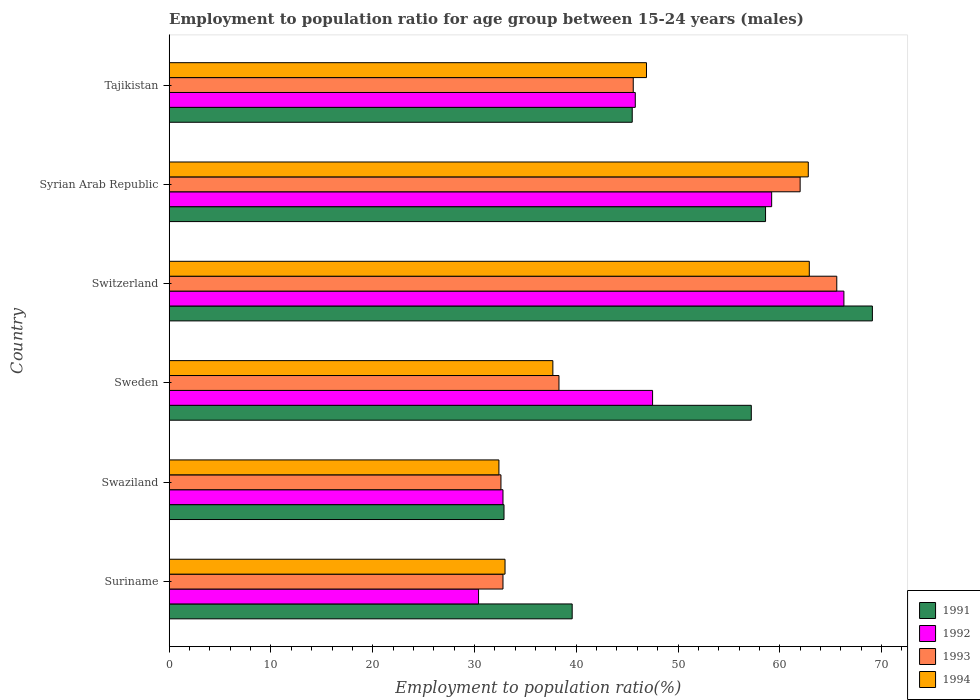How many groups of bars are there?
Offer a very short reply. 6. How many bars are there on the 6th tick from the top?
Offer a very short reply. 4. What is the label of the 1st group of bars from the top?
Give a very brief answer. Tajikistan. What is the employment to population ratio in 1991 in Swaziland?
Make the answer very short. 32.9. Across all countries, what is the maximum employment to population ratio in 1994?
Ensure brevity in your answer.  62.9. Across all countries, what is the minimum employment to population ratio in 1994?
Your response must be concise. 32.4. In which country was the employment to population ratio in 1992 maximum?
Offer a very short reply. Switzerland. In which country was the employment to population ratio in 1992 minimum?
Provide a short and direct response. Suriname. What is the total employment to population ratio in 1992 in the graph?
Keep it short and to the point. 282. What is the difference between the employment to population ratio in 1991 in Switzerland and that in Syrian Arab Republic?
Your answer should be compact. 10.5. What is the difference between the employment to population ratio in 1992 in Switzerland and the employment to population ratio in 1991 in Suriname?
Give a very brief answer. 26.7. What is the average employment to population ratio in 1994 per country?
Your response must be concise. 45.95. What is the ratio of the employment to population ratio in 1992 in Sweden to that in Tajikistan?
Give a very brief answer. 1.04. Is the employment to population ratio in 1992 in Suriname less than that in Swaziland?
Offer a terse response. Yes. What is the difference between the highest and the second highest employment to population ratio in 1991?
Provide a succinct answer. 10.5. What is the difference between the highest and the lowest employment to population ratio in 1994?
Your answer should be very brief. 30.5. Is it the case that in every country, the sum of the employment to population ratio in 1994 and employment to population ratio in 1992 is greater than the sum of employment to population ratio in 1993 and employment to population ratio in 1991?
Your answer should be compact. No. What does the 3rd bar from the bottom in Tajikistan represents?
Ensure brevity in your answer.  1993. Is it the case that in every country, the sum of the employment to population ratio in 1994 and employment to population ratio in 1992 is greater than the employment to population ratio in 1991?
Your response must be concise. Yes. How many countries are there in the graph?
Your response must be concise. 6. Does the graph contain grids?
Offer a terse response. No. Where does the legend appear in the graph?
Offer a terse response. Bottom right. How many legend labels are there?
Keep it short and to the point. 4. What is the title of the graph?
Your answer should be very brief. Employment to population ratio for age group between 15-24 years (males). Does "1966" appear as one of the legend labels in the graph?
Offer a terse response. No. What is the label or title of the Y-axis?
Give a very brief answer. Country. What is the Employment to population ratio(%) in 1991 in Suriname?
Keep it short and to the point. 39.6. What is the Employment to population ratio(%) in 1992 in Suriname?
Provide a short and direct response. 30.4. What is the Employment to population ratio(%) of 1993 in Suriname?
Give a very brief answer. 32.8. What is the Employment to population ratio(%) in 1994 in Suriname?
Make the answer very short. 33. What is the Employment to population ratio(%) in 1991 in Swaziland?
Your answer should be compact. 32.9. What is the Employment to population ratio(%) in 1992 in Swaziland?
Give a very brief answer. 32.8. What is the Employment to population ratio(%) of 1993 in Swaziland?
Provide a succinct answer. 32.6. What is the Employment to population ratio(%) in 1994 in Swaziland?
Keep it short and to the point. 32.4. What is the Employment to population ratio(%) in 1991 in Sweden?
Provide a short and direct response. 57.2. What is the Employment to population ratio(%) of 1992 in Sweden?
Ensure brevity in your answer.  47.5. What is the Employment to population ratio(%) in 1993 in Sweden?
Provide a short and direct response. 38.3. What is the Employment to population ratio(%) in 1994 in Sweden?
Offer a terse response. 37.7. What is the Employment to population ratio(%) in 1991 in Switzerland?
Your answer should be very brief. 69.1. What is the Employment to population ratio(%) of 1992 in Switzerland?
Make the answer very short. 66.3. What is the Employment to population ratio(%) of 1993 in Switzerland?
Your answer should be compact. 65.6. What is the Employment to population ratio(%) of 1994 in Switzerland?
Ensure brevity in your answer.  62.9. What is the Employment to population ratio(%) of 1991 in Syrian Arab Republic?
Your response must be concise. 58.6. What is the Employment to population ratio(%) of 1992 in Syrian Arab Republic?
Offer a very short reply. 59.2. What is the Employment to population ratio(%) of 1993 in Syrian Arab Republic?
Make the answer very short. 62. What is the Employment to population ratio(%) of 1994 in Syrian Arab Republic?
Give a very brief answer. 62.8. What is the Employment to population ratio(%) in 1991 in Tajikistan?
Make the answer very short. 45.5. What is the Employment to population ratio(%) of 1992 in Tajikistan?
Make the answer very short. 45.8. What is the Employment to population ratio(%) in 1993 in Tajikistan?
Make the answer very short. 45.6. What is the Employment to population ratio(%) in 1994 in Tajikistan?
Give a very brief answer. 46.9. Across all countries, what is the maximum Employment to population ratio(%) in 1991?
Give a very brief answer. 69.1. Across all countries, what is the maximum Employment to population ratio(%) in 1992?
Provide a succinct answer. 66.3. Across all countries, what is the maximum Employment to population ratio(%) of 1993?
Make the answer very short. 65.6. Across all countries, what is the maximum Employment to population ratio(%) of 1994?
Provide a succinct answer. 62.9. Across all countries, what is the minimum Employment to population ratio(%) of 1991?
Your answer should be compact. 32.9. Across all countries, what is the minimum Employment to population ratio(%) of 1992?
Your response must be concise. 30.4. Across all countries, what is the minimum Employment to population ratio(%) in 1993?
Provide a short and direct response. 32.6. Across all countries, what is the minimum Employment to population ratio(%) in 1994?
Your answer should be very brief. 32.4. What is the total Employment to population ratio(%) of 1991 in the graph?
Make the answer very short. 302.9. What is the total Employment to population ratio(%) of 1992 in the graph?
Provide a succinct answer. 282. What is the total Employment to population ratio(%) in 1993 in the graph?
Offer a very short reply. 276.9. What is the total Employment to population ratio(%) of 1994 in the graph?
Offer a very short reply. 275.7. What is the difference between the Employment to population ratio(%) of 1992 in Suriname and that in Swaziland?
Your answer should be very brief. -2.4. What is the difference between the Employment to population ratio(%) in 1991 in Suriname and that in Sweden?
Provide a succinct answer. -17.6. What is the difference between the Employment to population ratio(%) in 1992 in Suriname and that in Sweden?
Give a very brief answer. -17.1. What is the difference between the Employment to population ratio(%) in 1993 in Suriname and that in Sweden?
Your answer should be very brief. -5.5. What is the difference between the Employment to population ratio(%) in 1994 in Suriname and that in Sweden?
Offer a very short reply. -4.7. What is the difference between the Employment to population ratio(%) in 1991 in Suriname and that in Switzerland?
Give a very brief answer. -29.5. What is the difference between the Employment to population ratio(%) of 1992 in Suriname and that in Switzerland?
Offer a terse response. -35.9. What is the difference between the Employment to population ratio(%) of 1993 in Suriname and that in Switzerland?
Provide a short and direct response. -32.8. What is the difference between the Employment to population ratio(%) in 1994 in Suriname and that in Switzerland?
Keep it short and to the point. -29.9. What is the difference between the Employment to population ratio(%) of 1991 in Suriname and that in Syrian Arab Republic?
Offer a terse response. -19. What is the difference between the Employment to population ratio(%) of 1992 in Suriname and that in Syrian Arab Republic?
Ensure brevity in your answer.  -28.8. What is the difference between the Employment to population ratio(%) of 1993 in Suriname and that in Syrian Arab Republic?
Your response must be concise. -29.2. What is the difference between the Employment to population ratio(%) in 1994 in Suriname and that in Syrian Arab Republic?
Ensure brevity in your answer.  -29.8. What is the difference between the Employment to population ratio(%) in 1992 in Suriname and that in Tajikistan?
Offer a terse response. -15.4. What is the difference between the Employment to population ratio(%) of 1991 in Swaziland and that in Sweden?
Provide a succinct answer. -24.3. What is the difference between the Employment to population ratio(%) in 1992 in Swaziland and that in Sweden?
Your response must be concise. -14.7. What is the difference between the Employment to population ratio(%) in 1991 in Swaziland and that in Switzerland?
Provide a succinct answer. -36.2. What is the difference between the Employment to population ratio(%) of 1992 in Swaziland and that in Switzerland?
Ensure brevity in your answer.  -33.5. What is the difference between the Employment to population ratio(%) of 1993 in Swaziland and that in Switzerland?
Make the answer very short. -33. What is the difference between the Employment to population ratio(%) in 1994 in Swaziland and that in Switzerland?
Keep it short and to the point. -30.5. What is the difference between the Employment to population ratio(%) of 1991 in Swaziland and that in Syrian Arab Republic?
Offer a terse response. -25.7. What is the difference between the Employment to population ratio(%) in 1992 in Swaziland and that in Syrian Arab Republic?
Provide a succinct answer. -26.4. What is the difference between the Employment to population ratio(%) of 1993 in Swaziland and that in Syrian Arab Republic?
Provide a succinct answer. -29.4. What is the difference between the Employment to population ratio(%) of 1994 in Swaziland and that in Syrian Arab Republic?
Your answer should be compact. -30.4. What is the difference between the Employment to population ratio(%) in 1992 in Swaziland and that in Tajikistan?
Keep it short and to the point. -13. What is the difference between the Employment to population ratio(%) in 1993 in Swaziland and that in Tajikistan?
Your response must be concise. -13. What is the difference between the Employment to population ratio(%) in 1994 in Swaziland and that in Tajikistan?
Offer a terse response. -14.5. What is the difference between the Employment to population ratio(%) of 1991 in Sweden and that in Switzerland?
Provide a short and direct response. -11.9. What is the difference between the Employment to population ratio(%) of 1992 in Sweden and that in Switzerland?
Your answer should be very brief. -18.8. What is the difference between the Employment to population ratio(%) in 1993 in Sweden and that in Switzerland?
Offer a very short reply. -27.3. What is the difference between the Employment to population ratio(%) of 1994 in Sweden and that in Switzerland?
Make the answer very short. -25.2. What is the difference between the Employment to population ratio(%) in 1993 in Sweden and that in Syrian Arab Republic?
Offer a terse response. -23.7. What is the difference between the Employment to population ratio(%) of 1994 in Sweden and that in Syrian Arab Republic?
Your response must be concise. -25.1. What is the difference between the Employment to population ratio(%) of 1991 in Sweden and that in Tajikistan?
Give a very brief answer. 11.7. What is the difference between the Employment to population ratio(%) of 1992 in Sweden and that in Tajikistan?
Your response must be concise. 1.7. What is the difference between the Employment to population ratio(%) of 1993 in Sweden and that in Tajikistan?
Give a very brief answer. -7.3. What is the difference between the Employment to population ratio(%) of 1991 in Switzerland and that in Syrian Arab Republic?
Your answer should be very brief. 10.5. What is the difference between the Employment to population ratio(%) in 1992 in Switzerland and that in Syrian Arab Republic?
Offer a very short reply. 7.1. What is the difference between the Employment to population ratio(%) in 1993 in Switzerland and that in Syrian Arab Republic?
Give a very brief answer. 3.6. What is the difference between the Employment to population ratio(%) in 1994 in Switzerland and that in Syrian Arab Republic?
Your answer should be very brief. 0.1. What is the difference between the Employment to population ratio(%) in 1991 in Switzerland and that in Tajikistan?
Make the answer very short. 23.6. What is the difference between the Employment to population ratio(%) of 1991 in Syrian Arab Republic and that in Tajikistan?
Offer a terse response. 13.1. What is the difference between the Employment to population ratio(%) of 1994 in Syrian Arab Republic and that in Tajikistan?
Keep it short and to the point. 15.9. What is the difference between the Employment to population ratio(%) in 1991 in Suriname and the Employment to population ratio(%) in 1993 in Swaziland?
Your answer should be compact. 7. What is the difference between the Employment to population ratio(%) in 1992 in Suriname and the Employment to population ratio(%) in 1994 in Swaziland?
Your answer should be very brief. -2. What is the difference between the Employment to population ratio(%) in 1991 in Suriname and the Employment to population ratio(%) in 1992 in Sweden?
Make the answer very short. -7.9. What is the difference between the Employment to population ratio(%) of 1992 in Suriname and the Employment to population ratio(%) of 1993 in Sweden?
Offer a terse response. -7.9. What is the difference between the Employment to population ratio(%) in 1991 in Suriname and the Employment to population ratio(%) in 1992 in Switzerland?
Your response must be concise. -26.7. What is the difference between the Employment to population ratio(%) of 1991 in Suriname and the Employment to population ratio(%) of 1993 in Switzerland?
Provide a short and direct response. -26. What is the difference between the Employment to population ratio(%) of 1991 in Suriname and the Employment to population ratio(%) of 1994 in Switzerland?
Offer a terse response. -23.3. What is the difference between the Employment to population ratio(%) in 1992 in Suriname and the Employment to population ratio(%) in 1993 in Switzerland?
Make the answer very short. -35.2. What is the difference between the Employment to population ratio(%) in 1992 in Suriname and the Employment to population ratio(%) in 1994 in Switzerland?
Offer a terse response. -32.5. What is the difference between the Employment to population ratio(%) in 1993 in Suriname and the Employment to population ratio(%) in 1994 in Switzerland?
Offer a very short reply. -30.1. What is the difference between the Employment to population ratio(%) of 1991 in Suriname and the Employment to population ratio(%) of 1992 in Syrian Arab Republic?
Your response must be concise. -19.6. What is the difference between the Employment to population ratio(%) in 1991 in Suriname and the Employment to population ratio(%) in 1993 in Syrian Arab Republic?
Your response must be concise. -22.4. What is the difference between the Employment to population ratio(%) in 1991 in Suriname and the Employment to population ratio(%) in 1994 in Syrian Arab Republic?
Offer a terse response. -23.2. What is the difference between the Employment to population ratio(%) in 1992 in Suriname and the Employment to population ratio(%) in 1993 in Syrian Arab Republic?
Provide a short and direct response. -31.6. What is the difference between the Employment to population ratio(%) in 1992 in Suriname and the Employment to population ratio(%) in 1994 in Syrian Arab Republic?
Give a very brief answer. -32.4. What is the difference between the Employment to population ratio(%) in 1993 in Suriname and the Employment to population ratio(%) in 1994 in Syrian Arab Republic?
Provide a succinct answer. -30. What is the difference between the Employment to population ratio(%) in 1991 in Suriname and the Employment to population ratio(%) in 1992 in Tajikistan?
Offer a very short reply. -6.2. What is the difference between the Employment to population ratio(%) in 1991 in Suriname and the Employment to population ratio(%) in 1993 in Tajikistan?
Give a very brief answer. -6. What is the difference between the Employment to population ratio(%) of 1991 in Suriname and the Employment to population ratio(%) of 1994 in Tajikistan?
Offer a terse response. -7.3. What is the difference between the Employment to population ratio(%) in 1992 in Suriname and the Employment to population ratio(%) in 1993 in Tajikistan?
Provide a succinct answer. -15.2. What is the difference between the Employment to population ratio(%) in 1992 in Suriname and the Employment to population ratio(%) in 1994 in Tajikistan?
Keep it short and to the point. -16.5. What is the difference between the Employment to population ratio(%) of 1993 in Suriname and the Employment to population ratio(%) of 1994 in Tajikistan?
Your response must be concise. -14.1. What is the difference between the Employment to population ratio(%) of 1991 in Swaziland and the Employment to population ratio(%) of 1992 in Sweden?
Provide a succinct answer. -14.6. What is the difference between the Employment to population ratio(%) of 1991 in Swaziland and the Employment to population ratio(%) of 1992 in Switzerland?
Your response must be concise. -33.4. What is the difference between the Employment to population ratio(%) of 1991 in Swaziland and the Employment to population ratio(%) of 1993 in Switzerland?
Give a very brief answer. -32.7. What is the difference between the Employment to population ratio(%) of 1991 in Swaziland and the Employment to population ratio(%) of 1994 in Switzerland?
Provide a succinct answer. -30. What is the difference between the Employment to population ratio(%) of 1992 in Swaziland and the Employment to population ratio(%) of 1993 in Switzerland?
Ensure brevity in your answer.  -32.8. What is the difference between the Employment to population ratio(%) of 1992 in Swaziland and the Employment to population ratio(%) of 1994 in Switzerland?
Give a very brief answer. -30.1. What is the difference between the Employment to population ratio(%) of 1993 in Swaziland and the Employment to population ratio(%) of 1994 in Switzerland?
Provide a succinct answer. -30.3. What is the difference between the Employment to population ratio(%) of 1991 in Swaziland and the Employment to population ratio(%) of 1992 in Syrian Arab Republic?
Make the answer very short. -26.3. What is the difference between the Employment to population ratio(%) of 1991 in Swaziland and the Employment to population ratio(%) of 1993 in Syrian Arab Republic?
Make the answer very short. -29.1. What is the difference between the Employment to population ratio(%) in 1991 in Swaziland and the Employment to population ratio(%) in 1994 in Syrian Arab Republic?
Ensure brevity in your answer.  -29.9. What is the difference between the Employment to population ratio(%) of 1992 in Swaziland and the Employment to population ratio(%) of 1993 in Syrian Arab Republic?
Offer a terse response. -29.2. What is the difference between the Employment to population ratio(%) of 1992 in Swaziland and the Employment to population ratio(%) of 1994 in Syrian Arab Republic?
Your answer should be very brief. -30. What is the difference between the Employment to population ratio(%) in 1993 in Swaziland and the Employment to population ratio(%) in 1994 in Syrian Arab Republic?
Make the answer very short. -30.2. What is the difference between the Employment to population ratio(%) of 1991 in Swaziland and the Employment to population ratio(%) of 1992 in Tajikistan?
Offer a very short reply. -12.9. What is the difference between the Employment to population ratio(%) of 1991 in Swaziland and the Employment to population ratio(%) of 1993 in Tajikistan?
Make the answer very short. -12.7. What is the difference between the Employment to population ratio(%) of 1992 in Swaziland and the Employment to population ratio(%) of 1993 in Tajikistan?
Keep it short and to the point. -12.8. What is the difference between the Employment to population ratio(%) of 1992 in Swaziland and the Employment to population ratio(%) of 1994 in Tajikistan?
Your response must be concise. -14.1. What is the difference between the Employment to population ratio(%) of 1993 in Swaziland and the Employment to population ratio(%) of 1994 in Tajikistan?
Ensure brevity in your answer.  -14.3. What is the difference between the Employment to population ratio(%) of 1991 in Sweden and the Employment to population ratio(%) of 1992 in Switzerland?
Keep it short and to the point. -9.1. What is the difference between the Employment to population ratio(%) in 1991 in Sweden and the Employment to population ratio(%) in 1994 in Switzerland?
Provide a short and direct response. -5.7. What is the difference between the Employment to population ratio(%) in 1992 in Sweden and the Employment to population ratio(%) in 1993 in Switzerland?
Ensure brevity in your answer.  -18.1. What is the difference between the Employment to population ratio(%) of 1992 in Sweden and the Employment to population ratio(%) of 1994 in Switzerland?
Offer a terse response. -15.4. What is the difference between the Employment to population ratio(%) in 1993 in Sweden and the Employment to population ratio(%) in 1994 in Switzerland?
Offer a terse response. -24.6. What is the difference between the Employment to population ratio(%) in 1991 in Sweden and the Employment to population ratio(%) in 1993 in Syrian Arab Republic?
Offer a very short reply. -4.8. What is the difference between the Employment to population ratio(%) in 1992 in Sweden and the Employment to population ratio(%) in 1993 in Syrian Arab Republic?
Offer a very short reply. -14.5. What is the difference between the Employment to population ratio(%) of 1992 in Sweden and the Employment to population ratio(%) of 1994 in Syrian Arab Republic?
Your response must be concise. -15.3. What is the difference between the Employment to population ratio(%) of 1993 in Sweden and the Employment to population ratio(%) of 1994 in Syrian Arab Republic?
Provide a succinct answer. -24.5. What is the difference between the Employment to population ratio(%) in 1991 in Sweden and the Employment to population ratio(%) in 1992 in Tajikistan?
Make the answer very short. 11.4. What is the difference between the Employment to population ratio(%) of 1992 in Sweden and the Employment to population ratio(%) of 1994 in Tajikistan?
Give a very brief answer. 0.6. What is the difference between the Employment to population ratio(%) of 1993 in Switzerland and the Employment to population ratio(%) of 1994 in Syrian Arab Republic?
Your answer should be very brief. 2.8. What is the difference between the Employment to population ratio(%) in 1991 in Switzerland and the Employment to population ratio(%) in 1992 in Tajikistan?
Ensure brevity in your answer.  23.3. What is the difference between the Employment to population ratio(%) in 1991 in Switzerland and the Employment to population ratio(%) in 1993 in Tajikistan?
Your response must be concise. 23.5. What is the difference between the Employment to population ratio(%) in 1991 in Switzerland and the Employment to population ratio(%) in 1994 in Tajikistan?
Make the answer very short. 22.2. What is the difference between the Employment to population ratio(%) of 1992 in Switzerland and the Employment to population ratio(%) of 1993 in Tajikistan?
Keep it short and to the point. 20.7. What is the difference between the Employment to population ratio(%) of 1992 in Switzerland and the Employment to population ratio(%) of 1994 in Tajikistan?
Offer a terse response. 19.4. What is the difference between the Employment to population ratio(%) of 1991 in Syrian Arab Republic and the Employment to population ratio(%) of 1992 in Tajikistan?
Your answer should be very brief. 12.8. What is the difference between the Employment to population ratio(%) of 1991 in Syrian Arab Republic and the Employment to population ratio(%) of 1993 in Tajikistan?
Your answer should be compact. 13. What is the difference between the Employment to population ratio(%) of 1992 in Syrian Arab Republic and the Employment to population ratio(%) of 1993 in Tajikistan?
Give a very brief answer. 13.6. What is the difference between the Employment to population ratio(%) of 1992 in Syrian Arab Republic and the Employment to population ratio(%) of 1994 in Tajikistan?
Your answer should be very brief. 12.3. What is the difference between the Employment to population ratio(%) in 1993 in Syrian Arab Republic and the Employment to population ratio(%) in 1994 in Tajikistan?
Ensure brevity in your answer.  15.1. What is the average Employment to population ratio(%) of 1991 per country?
Give a very brief answer. 50.48. What is the average Employment to population ratio(%) of 1992 per country?
Offer a very short reply. 47. What is the average Employment to population ratio(%) in 1993 per country?
Provide a succinct answer. 46.15. What is the average Employment to population ratio(%) in 1994 per country?
Give a very brief answer. 45.95. What is the difference between the Employment to population ratio(%) in 1991 and Employment to population ratio(%) in 1992 in Suriname?
Keep it short and to the point. 9.2. What is the difference between the Employment to population ratio(%) in 1991 and Employment to population ratio(%) in 1993 in Suriname?
Give a very brief answer. 6.8. What is the difference between the Employment to population ratio(%) of 1991 and Employment to population ratio(%) of 1994 in Suriname?
Provide a succinct answer. 6.6. What is the difference between the Employment to population ratio(%) in 1992 and Employment to population ratio(%) in 1993 in Suriname?
Offer a terse response. -2.4. What is the difference between the Employment to population ratio(%) of 1991 and Employment to population ratio(%) of 1994 in Swaziland?
Give a very brief answer. 0.5. What is the difference between the Employment to population ratio(%) in 1992 and Employment to population ratio(%) in 1994 in Swaziland?
Provide a succinct answer. 0.4. What is the difference between the Employment to population ratio(%) in 1991 and Employment to population ratio(%) in 1992 in Sweden?
Ensure brevity in your answer.  9.7. What is the difference between the Employment to population ratio(%) of 1991 and Employment to population ratio(%) of 1993 in Sweden?
Your response must be concise. 18.9. What is the difference between the Employment to population ratio(%) in 1992 and Employment to population ratio(%) in 1994 in Sweden?
Make the answer very short. 9.8. What is the difference between the Employment to population ratio(%) in 1993 and Employment to population ratio(%) in 1994 in Sweden?
Your response must be concise. 0.6. What is the difference between the Employment to population ratio(%) in 1991 and Employment to population ratio(%) in 1992 in Switzerland?
Ensure brevity in your answer.  2.8. What is the difference between the Employment to population ratio(%) of 1991 and Employment to population ratio(%) of 1993 in Switzerland?
Ensure brevity in your answer.  3.5. What is the difference between the Employment to population ratio(%) of 1991 and Employment to population ratio(%) of 1994 in Switzerland?
Keep it short and to the point. 6.2. What is the difference between the Employment to population ratio(%) of 1993 and Employment to population ratio(%) of 1994 in Switzerland?
Your answer should be compact. 2.7. What is the difference between the Employment to population ratio(%) of 1991 and Employment to population ratio(%) of 1993 in Syrian Arab Republic?
Provide a succinct answer. -3.4. What is the difference between the Employment to population ratio(%) in 1991 and Employment to population ratio(%) in 1994 in Syrian Arab Republic?
Provide a short and direct response. -4.2. What is the difference between the Employment to population ratio(%) in 1992 and Employment to population ratio(%) in 1994 in Syrian Arab Republic?
Keep it short and to the point. -3.6. What is the difference between the Employment to population ratio(%) in 1993 and Employment to population ratio(%) in 1994 in Syrian Arab Republic?
Provide a succinct answer. -0.8. What is the difference between the Employment to population ratio(%) of 1991 and Employment to population ratio(%) of 1994 in Tajikistan?
Provide a short and direct response. -1.4. What is the difference between the Employment to population ratio(%) of 1993 and Employment to population ratio(%) of 1994 in Tajikistan?
Keep it short and to the point. -1.3. What is the ratio of the Employment to population ratio(%) of 1991 in Suriname to that in Swaziland?
Your answer should be compact. 1.2. What is the ratio of the Employment to population ratio(%) in 1992 in Suriname to that in Swaziland?
Your answer should be compact. 0.93. What is the ratio of the Employment to population ratio(%) of 1993 in Suriname to that in Swaziland?
Provide a short and direct response. 1.01. What is the ratio of the Employment to population ratio(%) in 1994 in Suriname to that in Swaziland?
Make the answer very short. 1.02. What is the ratio of the Employment to population ratio(%) in 1991 in Suriname to that in Sweden?
Your response must be concise. 0.69. What is the ratio of the Employment to population ratio(%) of 1992 in Suriname to that in Sweden?
Give a very brief answer. 0.64. What is the ratio of the Employment to population ratio(%) in 1993 in Suriname to that in Sweden?
Offer a terse response. 0.86. What is the ratio of the Employment to population ratio(%) in 1994 in Suriname to that in Sweden?
Provide a succinct answer. 0.88. What is the ratio of the Employment to population ratio(%) in 1991 in Suriname to that in Switzerland?
Your answer should be compact. 0.57. What is the ratio of the Employment to population ratio(%) in 1992 in Suriname to that in Switzerland?
Ensure brevity in your answer.  0.46. What is the ratio of the Employment to population ratio(%) of 1993 in Suriname to that in Switzerland?
Ensure brevity in your answer.  0.5. What is the ratio of the Employment to population ratio(%) of 1994 in Suriname to that in Switzerland?
Give a very brief answer. 0.52. What is the ratio of the Employment to population ratio(%) in 1991 in Suriname to that in Syrian Arab Republic?
Offer a very short reply. 0.68. What is the ratio of the Employment to population ratio(%) in 1992 in Suriname to that in Syrian Arab Republic?
Your answer should be compact. 0.51. What is the ratio of the Employment to population ratio(%) in 1993 in Suriname to that in Syrian Arab Republic?
Provide a short and direct response. 0.53. What is the ratio of the Employment to population ratio(%) of 1994 in Suriname to that in Syrian Arab Republic?
Offer a terse response. 0.53. What is the ratio of the Employment to population ratio(%) of 1991 in Suriname to that in Tajikistan?
Make the answer very short. 0.87. What is the ratio of the Employment to population ratio(%) of 1992 in Suriname to that in Tajikistan?
Your response must be concise. 0.66. What is the ratio of the Employment to population ratio(%) of 1993 in Suriname to that in Tajikistan?
Your response must be concise. 0.72. What is the ratio of the Employment to population ratio(%) in 1994 in Suriname to that in Tajikistan?
Make the answer very short. 0.7. What is the ratio of the Employment to population ratio(%) in 1991 in Swaziland to that in Sweden?
Your answer should be compact. 0.58. What is the ratio of the Employment to population ratio(%) of 1992 in Swaziland to that in Sweden?
Give a very brief answer. 0.69. What is the ratio of the Employment to population ratio(%) of 1993 in Swaziland to that in Sweden?
Offer a very short reply. 0.85. What is the ratio of the Employment to population ratio(%) in 1994 in Swaziland to that in Sweden?
Offer a terse response. 0.86. What is the ratio of the Employment to population ratio(%) in 1991 in Swaziland to that in Switzerland?
Offer a terse response. 0.48. What is the ratio of the Employment to population ratio(%) in 1992 in Swaziland to that in Switzerland?
Keep it short and to the point. 0.49. What is the ratio of the Employment to population ratio(%) of 1993 in Swaziland to that in Switzerland?
Keep it short and to the point. 0.5. What is the ratio of the Employment to population ratio(%) of 1994 in Swaziland to that in Switzerland?
Offer a terse response. 0.52. What is the ratio of the Employment to population ratio(%) of 1991 in Swaziland to that in Syrian Arab Republic?
Provide a short and direct response. 0.56. What is the ratio of the Employment to population ratio(%) in 1992 in Swaziland to that in Syrian Arab Republic?
Your response must be concise. 0.55. What is the ratio of the Employment to population ratio(%) of 1993 in Swaziland to that in Syrian Arab Republic?
Provide a succinct answer. 0.53. What is the ratio of the Employment to population ratio(%) of 1994 in Swaziland to that in Syrian Arab Republic?
Your answer should be compact. 0.52. What is the ratio of the Employment to population ratio(%) of 1991 in Swaziland to that in Tajikistan?
Provide a succinct answer. 0.72. What is the ratio of the Employment to population ratio(%) in 1992 in Swaziland to that in Tajikistan?
Make the answer very short. 0.72. What is the ratio of the Employment to population ratio(%) in 1993 in Swaziland to that in Tajikistan?
Give a very brief answer. 0.71. What is the ratio of the Employment to population ratio(%) of 1994 in Swaziland to that in Tajikistan?
Provide a succinct answer. 0.69. What is the ratio of the Employment to population ratio(%) in 1991 in Sweden to that in Switzerland?
Make the answer very short. 0.83. What is the ratio of the Employment to population ratio(%) in 1992 in Sweden to that in Switzerland?
Provide a short and direct response. 0.72. What is the ratio of the Employment to population ratio(%) of 1993 in Sweden to that in Switzerland?
Provide a short and direct response. 0.58. What is the ratio of the Employment to population ratio(%) of 1994 in Sweden to that in Switzerland?
Offer a very short reply. 0.6. What is the ratio of the Employment to population ratio(%) of 1991 in Sweden to that in Syrian Arab Republic?
Provide a succinct answer. 0.98. What is the ratio of the Employment to population ratio(%) of 1992 in Sweden to that in Syrian Arab Republic?
Your answer should be compact. 0.8. What is the ratio of the Employment to population ratio(%) in 1993 in Sweden to that in Syrian Arab Republic?
Make the answer very short. 0.62. What is the ratio of the Employment to population ratio(%) in 1994 in Sweden to that in Syrian Arab Republic?
Provide a short and direct response. 0.6. What is the ratio of the Employment to population ratio(%) of 1991 in Sweden to that in Tajikistan?
Offer a very short reply. 1.26. What is the ratio of the Employment to population ratio(%) in 1992 in Sweden to that in Tajikistan?
Ensure brevity in your answer.  1.04. What is the ratio of the Employment to population ratio(%) of 1993 in Sweden to that in Tajikistan?
Give a very brief answer. 0.84. What is the ratio of the Employment to population ratio(%) in 1994 in Sweden to that in Tajikistan?
Keep it short and to the point. 0.8. What is the ratio of the Employment to population ratio(%) of 1991 in Switzerland to that in Syrian Arab Republic?
Offer a terse response. 1.18. What is the ratio of the Employment to population ratio(%) of 1992 in Switzerland to that in Syrian Arab Republic?
Offer a very short reply. 1.12. What is the ratio of the Employment to population ratio(%) of 1993 in Switzerland to that in Syrian Arab Republic?
Ensure brevity in your answer.  1.06. What is the ratio of the Employment to population ratio(%) in 1994 in Switzerland to that in Syrian Arab Republic?
Your answer should be very brief. 1. What is the ratio of the Employment to population ratio(%) in 1991 in Switzerland to that in Tajikistan?
Make the answer very short. 1.52. What is the ratio of the Employment to population ratio(%) in 1992 in Switzerland to that in Tajikistan?
Offer a terse response. 1.45. What is the ratio of the Employment to population ratio(%) in 1993 in Switzerland to that in Tajikistan?
Offer a very short reply. 1.44. What is the ratio of the Employment to population ratio(%) of 1994 in Switzerland to that in Tajikistan?
Give a very brief answer. 1.34. What is the ratio of the Employment to population ratio(%) of 1991 in Syrian Arab Republic to that in Tajikistan?
Make the answer very short. 1.29. What is the ratio of the Employment to population ratio(%) of 1992 in Syrian Arab Republic to that in Tajikistan?
Ensure brevity in your answer.  1.29. What is the ratio of the Employment to population ratio(%) in 1993 in Syrian Arab Republic to that in Tajikistan?
Your response must be concise. 1.36. What is the ratio of the Employment to population ratio(%) of 1994 in Syrian Arab Republic to that in Tajikistan?
Ensure brevity in your answer.  1.34. What is the difference between the highest and the second highest Employment to population ratio(%) in 1994?
Offer a very short reply. 0.1. What is the difference between the highest and the lowest Employment to population ratio(%) in 1991?
Offer a terse response. 36.2. What is the difference between the highest and the lowest Employment to population ratio(%) in 1992?
Offer a terse response. 35.9. What is the difference between the highest and the lowest Employment to population ratio(%) in 1993?
Keep it short and to the point. 33. What is the difference between the highest and the lowest Employment to population ratio(%) of 1994?
Provide a short and direct response. 30.5. 